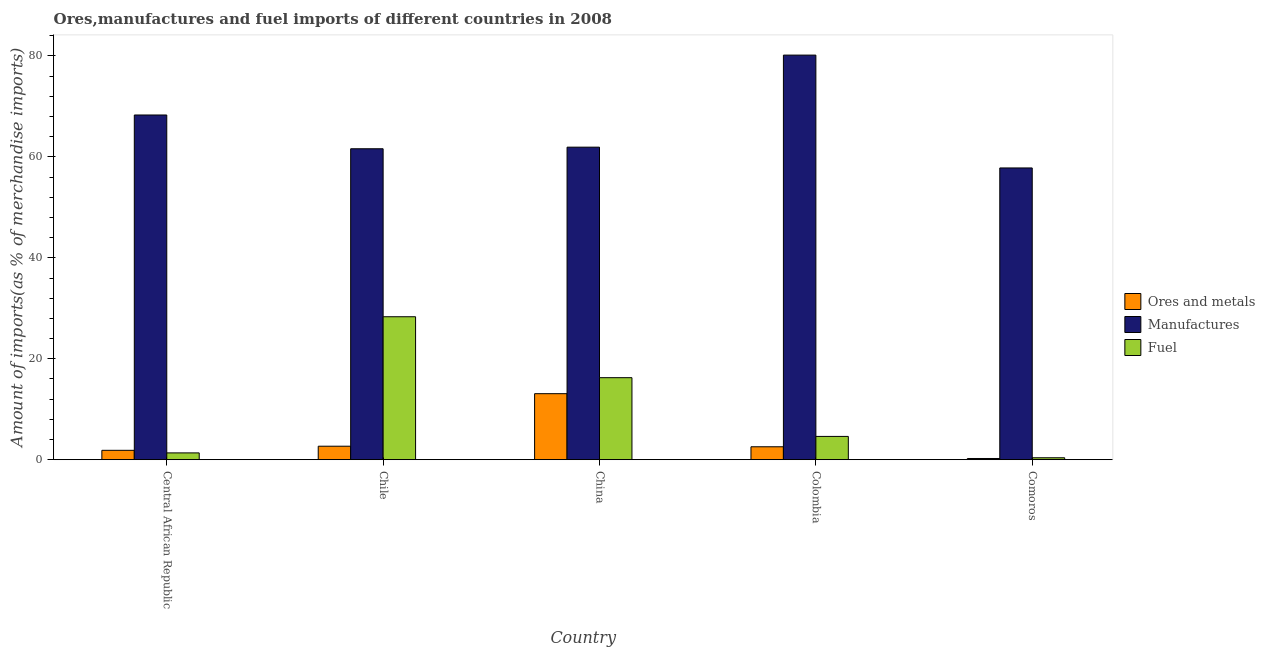How many different coloured bars are there?
Your answer should be compact. 3. Are the number of bars on each tick of the X-axis equal?
Make the answer very short. Yes. How many bars are there on the 2nd tick from the right?
Offer a very short reply. 3. What is the label of the 5th group of bars from the left?
Give a very brief answer. Comoros. What is the percentage of ores and metals imports in Colombia?
Offer a terse response. 2.56. Across all countries, what is the maximum percentage of fuel imports?
Offer a terse response. 28.33. Across all countries, what is the minimum percentage of manufactures imports?
Your answer should be compact. 57.81. In which country was the percentage of fuel imports minimum?
Provide a succinct answer. Comoros. What is the total percentage of fuel imports in the graph?
Your response must be concise. 50.92. What is the difference between the percentage of fuel imports in Chile and that in Comoros?
Make the answer very short. 27.94. What is the difference between the percentage of ores and metals imports in Comoros and the percentage of fuel imports in Central African Republic?
Provide a short and direct response. -1.11. What is the average percentage of fuel imports per country?
Offer a terse response. 10.18. What is the difference between the percentage of ores and metals imports and percentage of manufactures imports in Central African Republic?
Offer a very short reply. -66.45. In how many countries, is the percentage of fuel imports greater than 60 %?
Your answer should be very brief. 0. What is the ratio of the percentage of ores and metals imports in Central African Republic to that in Colombia?
Provide a succinct answer. 0.73. Is the percentage of manufactures imports in Chile less than that in China?
Provide a succinct answer. Yes. Is the difference between the percentage of ores and metals imports in Central African Republic and Comoros greater than the difference between the percentage of fuel imports in Central African Republic and Comoros?
Provide a succinct answer. Yes. What is the difference between the highest and the second highest percentage of ores and metals imports?
Your answer should be very brief. 10.41. What is the difference between the highest and the lowest percentage of manufactures imports?
Your response must be concise. 22.36. Is the sum of the percentage of ores and metals imports in Chile and Colombia greater than the maximum percentage of manufactures imports across all countries?
Give a very brief answer. No. What does the 2nd bar from the left in Colombia represents?
Provide a short and direct response. Manufactures. What does the 3rd bar from the right in Central African Republic represents?
Offer a terse response. Ores and metals. Are all the bars in the graph horizontal?
Ensure brevity in your answer.  No. What is the difference between two consecutive major ticks on the Y-axis?
Provide a short and direct response. 20. Are the values on the major ticks of Y-axis written in scientific E-notation?
Your answer should be very brief. No. Where does the legend appear in the graph?
Offer a very short reply. Center right. What is the title of the graph?
Offer a terse response. Ores,manufactures and fuel imports of different countries in 2008. What is the label or title of the Y-axis?
Give a very brief answer. Amount of imports(as % of merchandise imports). What is the Amount of imports(as % of merchandise imports) in Ores and metals in Central African Republic?
Offer a terse response. 1.86. What is the Amount of imports(as % of merchandise imports) in Manufactures in Central African Republic?
Your response must be concise. 68.3. What is the Amount of imports(as % of merchandise imports) in Fuel in Central African Republic?
Keep it short and to the point. 1.35. What is the Amount of imports(as % of merchandise imports) in Ores and metals in Chile?
Offer a very short reply. 2.67. What is the Amount of imports(as % of merchandise imports) in Manufactures in Chile?
Your response must be concise. 61.61. What is the Amount of imports(as % of merchandise imports) in Fuel in Chile?
Ensure brevity in your answer.  28.33. What is the Amount of imports(as % of merchandise imports) in Ores and metals in China?
Offer a terse response. 13.08. What is the Amount of imports(as % of merchandise imports) in Manufactures in China?
Provide a short and direct response. 61.93. What is the Amount of imports(as % of merchandise imports) of Fuel in China?
Ensure brevity in your answer.  16.25. What is the Amount of imports(as % of merchandise imports) of Ores and metals in Colombia?
Offer a terse response. 2.56. What is the Amount of imports(as % of merchandise imports) of Manufactures in Colombia?
Ensure brevity in your answer.  80.17. What is the Amount of imports(as % of merchandise imports) in Fuel in Colombia?
Keep it short and to the point. 4.61. What is the Amount of imports(as % of merchandise imports) of Ores and metals in Comoros?
Your answer should be compact. 0.24. What is the Amount of imports(as % of merchandise imports) in Manufactures in Comoros?
Make the answer very short. 57.81. What is the Amount of imports(as % of merchandise imports) in Fuel in Comoros?
Keep it short and to the point. 0.38. Across all countries, what is the maximum Amount of imports(as % of merchandise imports) in Ores and metals?
Provide a succinct answer. 13.08. Across all countries, what is the maximum Amount of imports(as % of merchandise imports) of Manufactures?
Provide a succinct answer. 80.17. Across all countries, what is the maximum Amount of imports(as % of merchandise imports) of Fuel?
Your answer should be compact. 28.33. Across all countries, what is the minimum Amount of imports(as % of merchandise imports) of Ores and metals?
Your response must be concise. 0.24. Across all countries, what is the minimum Amount of imports(as % of merchandise imports) of Manufactures?
Your answer should be compact. 57.81. Across all countries, what is the minimum Amount of imports(as % of merchandise imports) in Fuel?
Your answer should be compact. 0.38. What is the total Amount of imports(as % of merchandise imports) in Ores and metals in the graph?
Provide a short and direct response. 20.41. What is the total Amount of imports(as % of merchandise imports) in Manufactures in the graph?
Your answer should be very brief. 329.83. What is the total Amount of imports(as % of merchandise imports) in Fuel in the graph?
Offer a very short reply. 50.92. What is the difference between the Amount of imports(as % of merchandise imports) of Ores and metals in Central African Republic and that in Chile?
Your answer should be very brief. -0.81. What is the difference between the Amount of imports(as % of merchandise imports) in Manufactures in Central African Republic and that in Chile?
Ensure brevity in your answer.  6.69. What is the difference between the Amount of imports(as % of merchandise imports) in Fuel in Central African Republic and that in Chile?
Your answer should be very brief. -26.98. What is the difference between the Amount of imports(as % of merchandise imports) in Ores and metals in Central African Republic and that in China?
Offer a very short reply. -11.22. What is the difference between the Amount of imports(as % of merchandise imports) in Manufactures in Central African Republic and that in China?
Your response must be concise. 6.37. What is the difference between the Amount of imports(as % of merchandise imports) of Fuel in Central African Republic and that in China?
Your answer should be very brief. -14.9. What is the difference between the Amount of imports(as % of merchandise imports) of Ores and metals in Central African Republic and that in Colombia?
Ensure brevity in your answer.  -0.7. What is the difference between the Amount of imports(as % of merchandise imports) in Manufactures in Central African Republic and that in Colombia?
Offer a very short reply. -11.87. What is the difference between the Amount of imports(as % of merchandise imports) in Fuel in Central African Republic and that in Colombia?
Your answer should be compact. -3.27. What is the difference between the Amount of imports(as % of merchandise imports) in Ores and metals in Central African Republic and that in Comoros?
Keep it short and to the point. 1.62. What is the difference between the Amount of imports(as % of merchandise imports) of Manufactures in Central African Republic and that in Comoros?
Your answer should be very brief. 10.49. What is the difference between the Amount of imports(as % of merchandise imports) of Fuel in Central African Republic and that in Comoros?
Your answer should be compact. 0.96. What is the difference between the Amount of imports(as % of merchandise imports) in Ores and metals in Chile and that in China?
Provide a succinct answer. -10.41. What is the difference between the Amount of imports(as % of merchandise imports) in Manufactures in Chile and that in China?
Offer a terse response. -0.32. What is the difference between the Amount of imports(as % of merchandise imports) of Fuel in Chile and that in China?
Give a very brief answer. 12.08. What is the difference between the Amount of imports(as % of merchandise imports) of Ores and metals in Chile and that in Colombia?
Offer a very short reply. 0.11. What is the difference between the Amount of imports(as % of merchandise imports) in Manufactures in Chile and that in Colombia?
Offer a very short reply. -18.56. What is the difference between the Amount of imports(as % of merchandise imports) in Fuel in Chile and that in Colombia?
Ensure brevity in your answer.  23.71. What is the difference between the Amount of imports(as % of merchandise imports) in Ores and metals in Chile and that in Comoros?
Your answer should be very brief. 2.43. What is the difference between the Amount of imports(as % of merchandise imports) in Manufactures in Chile and that in Comoros?
Your answer should be very brief. 3.8. What is the difference between the Amount of imports(as % of merchandise imports) in Fuel in Chile and that in Comoros?
Provide a short and direct response. 27.94. What is the difference between the Amount of imports(as % of merchandise imports) of Ores and metals in China and that in Colombia?
Offer a very short reply. 10.52. What is the difference between the Amount of imports(as % of merchandise imports) in Manufactures in China and that in Colombia?
Give a very brief answer. -18.24. What is the difference between the Amount of imports(as % of merchandise imports) of Fuel in China and that in Colombia?
Offer a very short reply. 11.64. What is the difference between the Amount of imports(as % of merchandise imports) of Ores and metals in China and that in Comoros?
Your answer should be very brief. 12.84. What is the difference between the Amount of imports(as % of merchandise imports) of Manufactures in China and that in Comoros?
Offer a terse response. 4.12. What is the difference between the Amount of imports(as % of merchandise imports) in Fuel in China and that in Comoros?
Ensure brevity in your answer.  15.87. What is the difference between the Amount of imports(as % of merchandise imports) in Ores and metals in Colombia and that in Comoros?
Offer a very short reply. 2.32. What is the difference between the Amount of imports(as % of merchandise imports) in Manufactures in Colombia and that in Comoros?
Provide a succinct answer. 22.36. What is the difference between the Amount of imports(as % of merchandise imports) in Fuel in Colombia and that in Comoros?
Offer a terse response. 4.23. What is the difference between the Amount of imports(as % of merchandise imports) of Ores and metals in Central African Republic and the Amount of imports(as % of merchandise imports) of Manufactures in Chile?
Keep it short and to the point. -59.76. What is the difference between the Amount of imports(as % of merchandise imports) of Ores and metals in Central African Republic and the Amount of imports(as % of merchandise imports) of Fuel in Chile?
Your answer should be very brief. -26.47. What is the difference between the Amount of imports(as % of merchandise imports) in Manufactures in Central African Republic and the Amount of imports(as % of merchandise imports) in Fuel in Chile?
Offer a very short reply. 39.98. What is the difference between the Amount of imports(as % of merchandise imports) of Ores and metals in Central African Republic and the Amount of imports(as % of merchandise imports) of Manufactures in China?
Your answer should be compact. -60.07. What is the difference between the Amount of imports(as % of merchandise imports) in Ores and metals in Central African Republic and the Amount of imports(as % of merchandise imports) in Fuel in China?
Give a very brief answer. -14.39. What is the difference between the Amount of imports(as % of merchandise imports) in Manufactures in Central African Republic and the Amount of imports(as % of merchandise imports) in Fuel in China?
Give a very brief answer. 52.05. What is the difference between the Amount of imports(as % of merchandise imports) in Ores and metals in Central African Republic and the Amount of imports(as % of merchandise imports) in Manufactures in Colombia?
Keep it short and to the point. -78.31. What is the difference between the Amount of imports(as % of merchandise imports) in Ores and metals in Central African Republic and the Amount of imports(as % of merchandise imports) in Fuel in Colombia?
Offer a very short reply. -2.76. What is the difference between the Amount of imports(as % of merchandise imports) in Manufactures in Central African Republic and the Amount of imports(as % of merchandise imports) in Fuel in Colombia?
Give a very brief answer. 63.69. What is the difference between the Amount of imports(as % of merchandise imports) of Ores and metals in Central African Republic and the Amount of imports(as % of merchandise imports) of Manufactures in Comoros?
Offer a terse response. -55.95. What is the difference between the Amount of imports(as % of merchandise imports) in Ores and metals in Central African Republic and the Amount of imports(as % of merchandise imports) in Fuel in Comoros?
Provide a succinct answer. 1.47. What is the difference between the Amount of imports(as % of merchandise imports) of Manufactures in Central African Republic and the Amount of imports(as % of merchandise imports) of Fuel in Comoros?
Offer a very short reply. 67.92. What is the difference between the Amount of imports(as % of merchandise imports) of Ores and metals in Chile and the Amount of imports(as % of merchandise imports) of Manufactures in China?
Your answer should be compact. -59.26. What is the difference between the Amount of imports(as % of merchandise imports) in Ores and metals in Chile and the Amount of imports(as % of merchandise imports) in Fuel in China?
Offer a terse response. -13.58. What is the difference between the Amount of imports(as % of merchandise imports) of Manufactures in Chile and the Amount of imports(as % of merchandise imports) of Fuel in China?
Offer a very short reply. 45.36. What is the difference between the Amount of imports(as % of merchandise imports) of Ores and metals in Chile and the Amount of imports(as % of merchandise imports) of Manufactures in Colombia?
Your response must be concise. -77.5. What is the difference between the Amount of imports(as % of merchandise imports) of Ores and metals in Chile and the Amount of imports(as % of merchandise imports) of Fuel in Colombia?
Provide a succinct answer. -1.94. What is the difference between the Amount of imports(as % of merchandise imports) of Manufactures in Chile and the Amount of imports(as % of merchandise imports) of Fuel in Colombia?
Give a very brief answer. 57. What is the difference between the Amount of imports(as % of merchandise imports) of Ores and metals in Chile and the Amount of imports(as % of merchandise imports) of Manufactures in Comoros?
Offer a terse response. -55.14. What is the difference between the Amount of imports(as % of merchandise imports) in Ores and metals in Chile and the Amount of imports(as % of merchandise imports) in Fuel in Comoros?
Your response must be concise. 2.29. What is the difference between the Amount of imports(as % of merchandise imports) of Manufactures in Chile and the Amount of imports(as % of merchandise imports) of Fuel in Comoros?
Provide a succinct answer. 61.23. What is the difference between the Amount of imports(as % of merchandise imports) of Ores and metals in China and the Amount of imports(as % of merchandise imports) of Manufactures in Colombia?
Keep it short and to the point. -67.09. What is the difference between the Amount of imports(as % of merchandise imports) in Ores and metals in China and the Amount of imports(as % of merchandise imports) in Fuel in Colombia?
Your response must be concise. 8.47. What is the difference between the Amount of imports(as % of merchandise imports) of Manufactures in China and the Amount of imports(as % of merchandise imports) of Fuel in Colombia?
Offer a terse response. 57.32. What is the difference between the Amount of imports(as % of merchandise imports) in Ores and metals in China and the Amount of imports(as % of merchandise imports) in Manufactures in Comoros?
Provide a succinct answer. -44.73. What is the difference between the Amount of imports(as % of merchandise imports) in Ores and metals in China and the Amount of imports(as % of merchandise imports) in Fuel in Comoros?
Ensure brevity in your answer.  12.7. What is the difference between the Amount of imports(as % of merchandise imports) in Manufactures in China and the Amount of imports(as % of merchandise imports) in Fuel in Comoros?
Keep it short and to the point. 61.55. What is the difference between the Amount of imports(as % of merchandise imports) of Ores and metals in Colombia and the Amount of imports(as % of merchandise imports) of Manufactures in Comoros?
Provide a succinct answer. -55.25. What is the difference between the Amount of imports(as % of merchandise imports) in Ores and metals in Colombia and the Amount of imports(as % of merchandise imports) in Fuel in Comoros?
Give a very brief answer. 2.18. What is the difference between the Amount of imports(as % of merchandise imports) in Manufactures in Colombia and the Amount of imports(as % of merchandise imports) in Fuel in Comoros?
Ensure brevity in your answer.  79.79. What is the average Amount of imports(as % of merchandise imports) in Ores and metals per country?
Your response must be concise. 4.08. What is the average Amount of imports(as % of merchandise imports) of Manufactures per country?
Keep it short and to the point. 65.97. What is the average Amount of imports(as % of merchandise imports) of Fuel per country?
Provide a short and direct response. 10.18. What is the difference between the Amount of imports(as % of merchandise imports) in Ores and metals and Amount of imports(as % of merchandise imports) in Manufactures in Central African Republic?
Provide a succinct answer. -66.45. What is the difference between the Amount of imports(as % of merchandise imports) of Ores and metals and Amount of imports(as % of merchandise imports) of Fuel in Central African Republic?
Offer a very short reply. 0.51. What is the difference between the Amount of imports(as % of merchandise imports) of Manufactures and Amount of imports(as % of merchandise imports) of Fuel in Central African Republic?
Provide a succinct answer. 66.96. What is the difference between the Amount of imports(as % of merchandise imports) in Ores and metals and Amount of imports(as % of merchandise imports) in Manufactures in Chile?
Your response must be concise. -58.94. What is the difference between the Amount of imports(as % of merchandise imports) of Ores and metals and Amount of imports(as % of merchandise imports) of Fuel in Chile?
Ensure brevity in your answer.  -25.66. What is the difference between the Amount of imports(as % of merchandise imports) in Manufactures and Amount of imports(as % of merchandise imports) in Fuel in Chile?
Offer a terse response. 33.29. What is the difference between the Amount of imports(as % of merchandise imports) in Ores and metals and Amount of imports(as % of merchandise imports) in Manufactures in China?
Your answer should be very brief. -48.85. What is the difference between the Amount of imports(as % of merchandise imports) in Ores and metals and Amount of imports(as % of merchandise imports) in Fuel in China?
Your answer should be very brief. -3.17. What is the difference between the Amount of imports(as % of merchandise imports) in Manufactures and Amount of imports(as % of merchandise imports) in Fuel in China?
Your response must be concise. 45.68. What is the difference between the Amount of imports(as % of merchandise imports) of Ores and metals and Amount of imports(as % of merchandise imports) of Manufactures in Colombia?
Offer a very short reply. -77.61. What is the difference between the Amount of imports(as % of merchandise imports) in Ores and metals and Amount of imports(as % of merchandise imports) in Fuel in Colombia?
Give a very brief answer. -2.05. What is the difference between the Amount of imports(as % of merchandise imports) of Manufactures and Amount of imports(as % of merchandise imports) of Fuel in Colombia?
Provide a short and direct response. 75.56. What is the difference between the Amount of imports(as % of merchandise imports) in Ores and metals and Amount of imports(as % of merchandise imports) in Manufactures in Comoros?
Offer a terse response. -57.57. What is the difference between the Amount of imports(as % of merchandise imports) in Ores and metals and Amount of imports(as % of merchandise imports) in Fuel in Comoros?
Your answer should be very brief. -0.15. What is the difference between the Amount of imports(as % of merchandise imports) of Manufactures and Amount of imports(as % of merchandise imports) of Fuel in Comoros?
Offer a very short reply. 57.43. What is the ratio of the Amount of imports(as % of merchandise imports) in Ores and metals in Central African Republic to that in Chile?
Provide a succinct answer. 0.7. What is the ratio of the Amount of imports(as % of merchandise imports) in Manufactures in Central African Republic to that in Chile?
Ensure brevity in your answer.  1.11. What is the ratio of the Amount of imports(as % of merchandise imports) in Fuel in Central African Republic to that in Chile?
Your answer should be compact. 0.05. What is the ratio of the Amount of imports(as % of merchandise imports) of Ores and metals in Central African Republic to that in China?
Your response must be concise. 0.14. What is the ratio of the Amount of imports(as % of merchandise imports) of Manufactures in Central African Republic to that in China?
Give a very brief answer. 1.1. What is the ratio of the Amount of imports(as % of merchandise imports) in Fuel in Central African Republic to that in China?
Provide a short and direct response. 0.08. What is the ratio of the Amount of imports(as % of merchandise imports) in Ores and metals in Central African Republic to that in Colombia?
Your answer should be compact. 0.73. What is the ratio of the Amount of imports(as % of merchandise imports) of Manufactures in Central African Republic to that in Colombia?
Offer a very short reply. 0.85. What is the ratio of the Amount of imports(as % of merchandise imports) of Fuel in Central African Republic to that in Colombia?
Keep it short and to the point. 0.29. What is the ratio of the Amount of imports(as % of merchandise imports) in Ores and metals in Central African Republic to that in Comoros?
Your answer should be compact. 7.83. What is the ratio of the Amount of imports(as % of merchandise imports) in Manufactures in Central African Republic to that in Comoros?
Ensure brevity in your answer.  1.18. What is the ratio of the Amount of imports(as % of merchandise imports) of Fuel in Central African Republic to that in Comoros?
Provide a short and direct response. 3.51. What is the ratio of the Amount of imports(as % of merchandise imports) of Ores and metals in Chile to that in China?
Ensure brevity in your answer.  0.2. What is the ratio of the Amount of imports(as % of merchandise imports) of Fuel in Chile to that in China?
Keep it short and to the point. 1.74. What is the ratio of the Amount of imports(as % of merchandise imports) in Ores and metals in Chile to that in Colombia?
Your answer should be compact. 1.04. What is the ratio of the Amount of imports(as % of merchandise imports) of Manufactures in Chile to that in Colombia?
Your response must be concise. 0.77. What is the ratio of the Amount of imports(as % of merchandise imports) in Fuel in Chile to that in Colombia?
Offer a terse response. 6.14. What is the ratio of the Amount of imports(as % of merchandise imports) in Ores and metals in Chile to that in Comoros?
Keep it short and to the point. 11.26. What is the ratio of the Amount of imports(as % of merchandise imports) in Manufactures in Chile to that in Comoros?
Make the answer very short. 1.07. What is the ratio of the Amount of imports(as % of merchandise imports) of Fuel in Chile to that in Comoros?
Provide a succinct answer. 73.82. What is the ratio of the Amount of imports(as % of merchandise imports) in Ores and metals in China to that in Colombia?
Keep it short and to the point. 5.11. What is the ratio of the Amount of imports(as % of merchandise imports) in Manufactures in China to that in Colombia?
Offer a very short reply. 0.77. What is the ratio of the Amount of imports(as % of merchandise imports) of Fuel in China to that in Colombia?
Give a very brief answer. 3.52. What is the ratio of the Amount of imports(as % of merchandise imports) in Ores and metals in China to that in Comoros?
Your answer should be very brief. 55.11. What is the ratio of the Amount of imports(as % of merchandise imports) of Manufactures in China to that in Comoros?
Offer a terse response. 1.07. What is the ratio of the Amount of imports(as % of merchandise imports) in Fuel in China to that in Comoros?
Provide a short and direct response. 42.35. What is the ratio of the Amount of imports(as % of merchandise imports) of Ores and metals in Colombia to that in Comoros?
Your answer should be compact. 10.79. What is the ratio of the Amount of imports(as % of merchandise imports) of Manufactures in Colombia to that in Comoros?
Offer a very short reply. 1.39. What is the ratio of the Amount of imports(as % of merchandise imports) in Fuel in Colombia to that in Comoros?
Offer a terse response. 12.02. What is the difference between the highest and the second highest Amount of imports(as % of merchandise imports) in Ores and metals?
Ensure brevity in your answer.  10.41. What is the difference between the highest and the second highest Amount of imports(as % of merchandise imports) of Manufactures?
Give a very brief answer. 11.87. What is the difference between the highest and the second highest Amount of imports(as % of merchandise imports) of Fuel?
Provide a short and direct response. 12.08. What is the difference between the highest and the lowest Amount of imports(as % of merchandise imports) in Ores and metals?
Keep it short and to the point. 12.84. What is the difference between the highest and the lowest Amount of imports(as % of merchandise imports) in Manufactures?
Offer a terse response. 22.36. What is the difference between the highest and the lowest Amount of imports(as % of merchandise imports) of Fuel?
Ensure brevity in your answer.  27.94. 